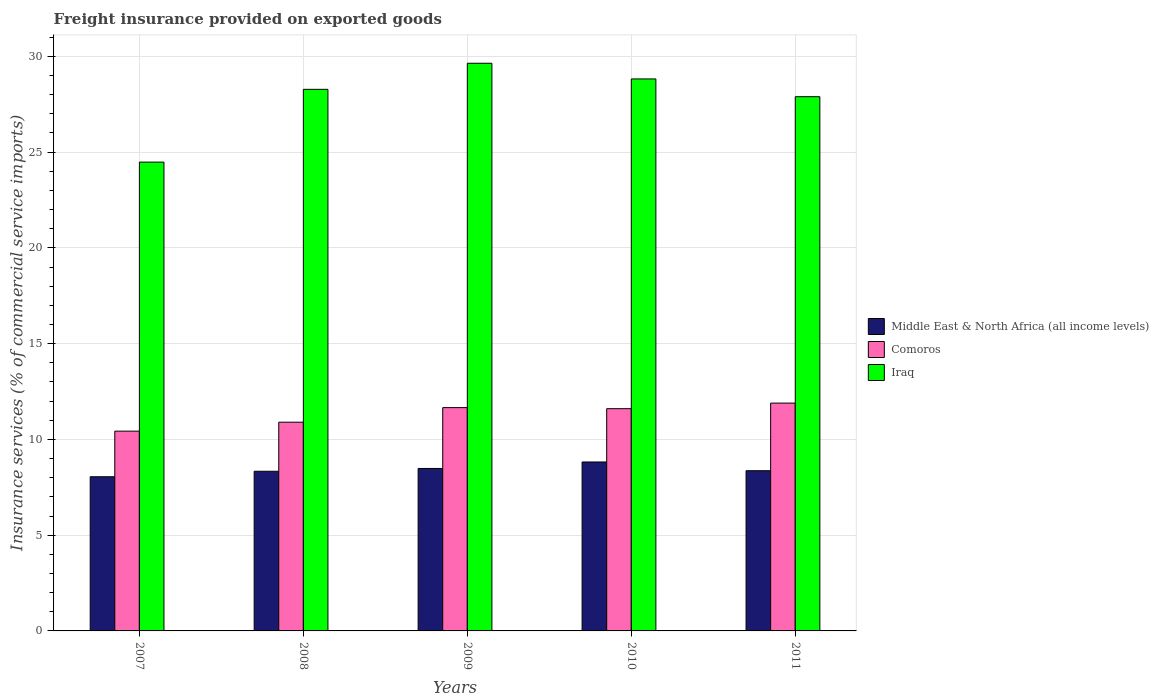How many different coloured bars are there?
Your response must be concise. 3. How many groups of bars are there?
Give a very brief answer. 5. How many bars are there on the 1st tick from the left?
Make the answer very short. 3. How many bars are there on the 4th tick from the right?
Provide a short and direct response. 3. What is the label of the 5th group of bars from the left?
Make the answer very short. 2011. What is the freight insurance provided on exported goods in Comoros in 2008?
Keep it short and to the point. 10.9. Across all years, what is the maximum freight insurance provided on exported goods in Middle East & North Africa (all income levels)?
Keep it short and to the point. 8.82. Across all years, what is the minimum freight insurance provided on exported goods in Comoros?
Ensure brevity in your answer.  10.43. What is the total freight insurance provided on exported goods in Iraq in the graph?
Ensure brevity in your answer.  139.11. What is the difference between the freight insurance provided on exported goods in Iraq in 2007 and that in 2010?
Give a very brief answer. -4.34. What is the difference between the freight insurance provided on exported goods in Middle East & North Africa (all income levels) in 2007 and the freight insurance provided on exported goods in Iraq in 2009?
Make the answer very short. -21.59. What is the average freight insurance provided on exported goods in Iraq per year?
Provide a short and direct response. 27.82. In the year 2009, what is the difference between the freight insurance provided on exported goods in Comoros and freight insurance provided on exported goods in Iraq?
Keep it short and to the point. -17.98. In how many years, is the freight insurance provided on exported goods in Middle East & North Africa (all income levels) greater than 30 %?
Your answer should be compact. 0. What is the ratio of the freight insurance provided on exported goods in Iraq in 2007 to that in 2011?
Ensure brevity in your answer.  0.88. Is the difference between the freight insurance provided on exported goods in Comoros in 2010 and 2011 greater than the difference between the freight insurance provided on exported goods in Iraq in 2010 and 2011?
Your answer should be very brief. No. What is the difference between the highest and the second highest freight insurance provided on exported goods in Iraq?
Make the answer very short. 0.82. What is the difference between the highest and the lowest freight insurance provided on exported goods in Comoros?
Your answer should be compact. 1.46. In how many years, is the freight insurance provided on exported goods in Comoros greater than the average freight insurance provided on exported goods in Comoros taken over all years?
Keep it short and to the point. 3. What does the 1st bar from the left in 2011 represents?
Your answer should be compact. Middle East & North Africa (all income levels). What does the 2nd bar from the right in 2008 represents?
Offer a very short reply. Comoros. Is it the case that in every year, the sum of the freight insurance provided on exported goods in Iraq and freight insurance provided on exported goods in Comoros is greater than the freight insurance provided on exported goods in Middle East & North Africa (all income levels)?
Offer a terse response. Yes. Does the graph contain any zero values?
Make the answer very short. No. Does the graph contain grids?
Provide a short and direct response. Yes. Where does the legend appear in the graph?
Offer a very short reply. Center right. How many legend labels are there?
Provide a short and direct response. 3. How are the legend labels stacked?
Make the answer very short. Vertical. What is the title of the graph?
Offer a very short reply. Freight insurance provided on exported goods. What is the label or title of the Y-axis?
Your answer should be very brief. Insurance services (% of commercial service imports). What is the Insurance services (% of commercial service imports) in Middle East & North Africa (all income levels) in 2007?
Offer a terse response. 8.05. What is the Insurance services (% of commercial service imports) in Comoros in 2007?
Offer a terse response. 10.43. What is the Insurance services (% of commercial service imports) of Iraq in 2007?
Ensure brevity in your answer.  24.48. What is the Insurance services (% of commercial service imports) in Middle East & North Africa (all income levels) in 2008?
Provide a succinct answer. 8.34. What is the Insurance services (% of commercial service imports) of Comoros in 2008?
Your answer should be very brief. 10.9. What is the Insurance services (% of commercial service imports) in Iraq in 2008?
Ensure brevity in your answer.  28.28. What is the Insurance services (% of commercial service imports) of Middle East & North Africa (all income levels) in 2009?
Your response must be concise. 8.48. What is the Insurance services (% of commercial service imports) of Comoros in 2009?
Provide a short and direct response. 11.66. What is the Insurance services (% of commercial service imports) of Iraq in 2009?
Provide a succinct answer. 29.64. What is the Insurance services (% of commercial service imports) of Middle East & North Africa (all income levels) in 2010?
Keep it short and to the point. 8.82. What is the Insurance services (% of commercial service imports) of Comoros in 2010?
Ensure brevity in your answer.  11.6. What is the Insurance services (% of commercial service imports) of Iraq in 2010?
Your response must be concise. 28.82. What is the Insurance services (% of commercial service imports) in Middle East & North Africa (all income levels) in 2011?
Make the answer very short. 8.36. What is the Insurance services (% of commercial service imports) in Comoros in 2011?
Make the answer very short. 11.9. What is the Insurance services (% of commercial service imports) of Iraq in 2011?
Provide a succinct answer. 27.89. Across all years, what is the maximum Insurance services (% of commercial service imports) in Middle East & North Africa (all income levels)?
Make the answer very short. 8.82. Across all years, what is the maximum Insurance services (% of commercial service imports) in Comoros?
Ensure brevity in your answer.  11.9. Across all years, what is the maximum Insurance services (% of commercial service imports) in Iraq?
Give a very brief answer. 29.64. Across all years, what is the minimum Insurance services (% of commercial service imports) in Middle East & North Africa (all income levels)?
Your response must be concise. 8.05. Across all years, what is the minimum Insurance services (% of commercial service imports) in Comoros?
Your answer should be compact. 10.43. Across all years, what is the minimum Insurance services (% of commercial service imports) of Iraq?
Offer a terse response. 24.48. What is the total Insurance services (% of commercial service imports) of Middle East & North Africa (all income levels) in the graph?
Your response must be concise. 42.05. What is the total Insurance services (% of commercial service imports) in Comoros in the graph?
Keep it short and to the point. 56.49. What is the total Insurance services (% of commercial service imports) in Iraq in the graph?
Offer a terse response. 139.11. What is the difference between the Insurance services (% of commercial service imports) of Middle East & North Africa (all income levels) in 2007 and that in 2008?
Your response must be concise. -0.29. What is the difference between the Insurance services (% of commercial service imports) of Comoros in 2007 and that in 2008?
Provide a short and direct response. -0.47. What is the difference between the Insurance services (% of commercial service imports) of Iraq in 2007 and that in 2008?
Your response must be concise. -3.8. What is the difference between the Insurance services (% of commercial service imports) in Middle East & North Africa (all income levels) in 2007 and that in 2009?
Provide a succinct answer. -0.43. What is the difference between the Insurance services (% of commercial service imports) of Comoros in 2007 and that in 2009?
Provide a short and direct response. -1.23. What is the difference between the Insurance services (% of commercial service imports) in Iraq in 2007 and that in 2009?
Provide a succinct answer. -5.16. What is the difference between the Insurance services (% of commercial service imports) of Middle East & North Africa (all income levels) in 2007 and that in 2010?
Your response must be concise. -0.77. What is the difference between the Insurance services (% of commercial service imports) in Comoros in 2007 and that in 2010?
Provide a succinct answer. -1.17. What is the difference between the Insurance services (% of commercial service imports) of Iraq in 2007 and that in 2010?
Your answer should be very brief. -4.34. What is the difference between the Insurance services (% of commercial service imports) of Middle East & North Africa (all income levels) in 2007 and that in 2011?
Ensure brevity in your answer.  -0.31. What is the difference between the Insurance services (% of commercial service imports) in Comoros in 2007 and that in 2011?
Provide a short and direct response. -1.46. What is the difference between the Insurance services (% of commercial service imports) of Iraq in 2007 and that in 2011?
Give a very brief answer. -3.42. What is the difference between the Insurance services (% of commercial service imports) of Middle East & North Africa (all income levels) in 2008 and that in 2009?
Keep it short and to the point. -0.15. What is the difference between the Insurance services (% of commercial service imports) of Comoros in 2008 and that in 2009?
Offer a terse response. -0.76. What is the difference between the Insurance services (% of commercial service imports) of Iraq in 2008 and that in 2009?
Provide a short and direct response. -1.36. What is the difference between the Insurance services (% of commercial service imports) in Middle East & North Africa (all income levels) in 2008 and that in 2010?
Provide a short and direct response. -0.48. What is the difference between the Insurance services (% of commercial service imports) in Comoros in 2008 and that in 2010?
Offer a very short reply. -0.71. What is the difference between the Insurance services (% of commercial service imports) in Iraq in 2008 and that in 2010?
Offer a very short reply. -0.54. What is the difference between the Insurance services (% of commercial service imports) in Middle East & North Africa (all income levels) in 2008 and that in 2011?
Offer a terse response. -0.03. What is the difference between the Insurance services (% of commercial service imports) in Comoros in 2008 and that in 2011?
Offer a very short reply. -1. What is the difference between the Insurance services (% of commercial service imports) of Iraq in 2008 and that in 2011?
Your response must be concise. 0.38. What is the difference between the Insurance services (% of commercial service imports) in Middle East & North Africa (all income levels) in 2009 and that in 2010?
Offer a terse response. -0.34. What is the difference between the Insurance services (% of commercial service imports) of Comoros in 2009 and that in 2010?
Make the answer very short. 0.06. What is the difference between the Insurance services (% of commercial service imports) in Iraq in 2009 and that in 2010?
Keep it short and to the point. 0.82. What is the difference between the Insurance services (% of commercial service imports) in Middle East & North Africa (all income levels) in 2009 and that in 2011?
Your answer should be compact. 0.12. What is the difference between the Insurance services (% of commercial service imports) in Comoros in 2009 and that in 2011?
Keep it short and to the point. -0.24. What is the difference between the Insurance services (% of commercial service imports) of Iraq in 2009 and that in 2011?
Your response must be concise. 1.75. What is the difference between the Insurance services (% of commercial service imports) of Middle East & North Africa (all income levels) in 2010 and that in 2011?
Your answer should be compact. 0.46. What is the difference between the Insurance services (% of commercial service imports) in Comoros in 2010 and that in 2011?
Your answer should be compact. -0.29. What is the difference between the Insurance services (% of commercial service imports) in Iraq in 2010 and that in 2011?
Make the answer very short. 0.93. What is the difference between the Insurance services (% of commercial service imports) of Middle East & North Africa (all income levels) in 2007 and the Insurance services (% of commercial service imports) of Comoros in 2008?
Keep it short and to the point. -2.85. What is the difference between the Insurance services (% of commercial service imports) of Middle East & North Africa (all income levels) in 2007 and the Insurance services (% of commercial service imports) of Iraq in 2008?
Provide a succinct answer. -20.23. What is the difference between the Insurance services (% of commercial service imports) in Comoros in 2007 and the Insurance services (% of commercial service imports) in Iraq in 2008?
Offer a very short reply. -17.85. What is the difference between the Insurance services (% of commercial service imports) in Middle East & North Africa (all income levels) in 2007 and the Insurance services (% of commercial service imports) in Comoros in 2009?
Provide a succinct answer. -3.61. What is the difference between the Insurance services (% of commercial service imports) of Middle East & North Africa (all income levels) in 2007 and the Insurance services (% of commercial service imports) of Iraq in 2009?
Offer a terse response. -21.59. What is the difference between the Insurance services (% of commercial service imports) in Comoros in 2007 and the Insurance services (% of commercial service imports) in Iraq in 2009?
Make the answer very short. -19.21. What is the difference between the Insurance services (% of commercial service imports) in Middle East & North Africa (all income levels) in 2007 and the Insurance services (% of commercial service imports) in Comoros in 2010?
Give a very brief answer. -3.55. What is the difference between the Insurance services (% of commercial service imports) of Middle East & North Africa (all income levels) in 2007 and the Insurance services (% of commercial service imports) of Iraq in 2010?
Your answer should be very brief. -20.77. What is the difference between the Insurance services (% of commercial service imports) of Comoros in 2007 and the Insurance services (% of commercial service imports) of Iraq in 2010?
Ensure brevity in your answer.  -18.39. What is the difference between the Insurance services (% of commercial service imports) in Middle East & North Africa (all income levels) in 2007 and the Insurance services (% of commercial service imports) in Comoros in 2011?
Your response must be concise. -3.85. What is the difference between the Insurance services (% of commercial service imports) of Middle East & North Africa (all income levels) in 2007 and the Insurance services (% of commercial service imports) of Iraq in 2011?
Ensure brevity in your answer.  -19.84. What is the difference between the Insurance services (% of commercial service imports) in Comoros in 2007 and the Insurance services (% of commercial service imports) in Iraq in 2011?
Provide a short and direct response. -17.46. What is the difference between the Insurance services (% of commercial service imports) of Middle East & North Africa (all income levels) in 2008 and the Insurance services (% of commercial service imports) of Comoros in 2009?
Provide a short and direct response. -3.32. What is the difference between the Insurance services (% of commercial service imports) of Middle East & North Africa (all income levels) in 2008 and the Insurance services (% of commercial service imports) of Iraq in 2009?
Give a very brief answer. -21.3. What is the difference between the Insurance services (% of commercial service imports) of Comoros in 2008 and the Insurance services (% of commercial service imports) of Iraq in 2009?
Keep it short and to the point. -18.74. What is the difference between the Insurance services (% of commercial service imports) in Middle East & North Africa (all income levels) in 2008 and the Insurance services (% of commercial service imports) in Comoros in 2010?
Provide a succinct answer. -3.27. What is the difference between the Insurance services (% of commercial service imports) in Middle East & North Africa (all income levels) in 2008 and the Insurance services (% of commercial service imports) in Iraq in 2010?
Your response must be concise. -20.48. What is the difference between the Insurance services (% of commercial service imports) in Comoros in 2008 and the Insurance services (% of commercial service imports) in Iraq in 2010?
Provide a short and direct response. -17.92. What is the difference between the Insurance services (% of commercial service imports) in Middle East & North Africa (all income levels) in 2008 and the Insurance services (% of commercial service imports) in Comoros in 2011?
Make the answer very short. -3.56. What is the difference between the Insurance services (% of commercial service imports) of Middle East & North Africa (all income levels) in 2008 and the Insurance services (% of commercial service imports) of Iraq in 2011?
Provide a short and direct response. -19.56. What is the difference between the Insurance services (% of commercial service imports) in Comoros in 2008 and the Insurance services (% of commercial service imports) in Iraq in 2011?
Your response must be concise. -17. What is the difference between the Insurance services (% of commercial service imports) in Middle East & North Africa (all income levels) in 2009 and the Insurance services (% of commercial service imports) in Comoros in 2010?
Offer a terse response. -3.12. What is the difference between the Insurance services (% of commercial service imports) of Middle East & North Africa (all income levels) in 2009 and the Insurance services (% of commercial service imports) of Iraq in 2010?
Your response must be concise. -20.34. What is the difference between the Insurance services (% of commercial service imports) in Comoros in 2009 and the Insurance services (% of commercial service imports) in Iraq in 2010?
Offer a terse response. -17.16. What is the difference between the Insurance services (% of commercial service imports) in Middle East & North Africa (all income levels) in 2009 and the Insurance services (% of commercial service imports) in Comoros in 2011?
Your response must be concise. -3.41. What is the difference between the Insurance services (% of commercial service imports) of Middle East & North Africa (all income levels) in 2009 and the Insurance services (% of commercial service imports) of Iraq in 2011?
Your answer should be compact. -19.41. What is the difference between the Insurance services (% of commercial service imports) of Comoros in 2009 and the Insurance services (% of commercial service imports) of Iraq in 2011?
Make the answer very short. -16.23. What is the difference between the Insurance services (% of commercial service imports) of Middle East & North Africa (all income levels) in 2010 and the Insurance services (% of commercial service imports) of Comoros in 2011?
Make the answer very short. -3.07. What is the difference between the Insurance services (% of commercial service imports) of Middle East & North Africa (all income levels) in 2010 and the Insurance services (% of commercial service imports) of Iraq in 2011?
Your answer should be very brief. -19.07. What is the difference between the Insurance services (% of commercial service imports) of Comoros in 2010 and the Insurance services (% of commercial service imports) of Iraq in 2011?
Your answer should be compact. -16.29. What is the average Insurance services (% of commercial service imports) of Middle East & North Africa (all income levels) per year?
Keep it short and to the point. 8.41. What is the average Insurance services (% of commercial service imports) in Comoros per year?
Provide a short and direct response. 11.3. What is the average Insurance services (% of commercial service imports) of Iraq per year?
Your response must be concise. 27.82. In the year 2007, what is the difference between the Insurance services (% of commercial service imports) of Middle East & North Africa (all income levels) and Insurance services (% of commercial service imports) of Comoros?
Make the answer very short. -2.38. In the year 2007, what is the difference between the Insurance services (% of commercial service imports) of Middle East & North Africa (all income levels) and Insurance services (% of commercial service imports) of Iraq?
Make the answer very short. -16.43. In the year 2007, what is the difference between the Insurance services (% of commercial service imports) of Comoros and Insurance services (% of commercial service imports) of Iraq?
Give a very brief answer. -14.05. In the year 2008, what is the difference between the Insurance services (% of commercial service imports) of Middle East & North Africa (all income levels) and Insurance services (% of commercial service imports) of Comoros?
Keep it short and to the point. -2.56. In the year 2008, what is the difference between the Insurance services (% of commercial service imports) in Middle East & North Africa (all income levels) and Insurance services (% of commercial service imports) in Iraq?
Provide a succinct answer. -19.94. In the year 2008, what is the difference between the Insurance services (% of commercial service imports) in Comoros and Insurance services (% of commercial service imports) in Iraq?
Offer a very short reply. -17.38. In the year 2009, what is the difference between the Insurance services (% of commercial service imports) of Middle East & North Africa (all income levels) and Insurance services (% of commercial service imports) of Comoros?
Give a very brief answer. -3.18. In the year 2009, what is the difference between the Insurance services (% of commercial service imports) in Middle East & North Africa (all income levels) and Insurance services (% of commercial service imports) in Iraq?
Give a very brief answer. -21.16. In the year 2009, what is the difference between the Insurance services (% of commercial service imports) of Comoros and Insurance services (% of commercial service imports) of Iraq?
Offer a terse response. -17.98. In the year 2010, what is the difference between the Insurance services (% of commercial service imports) of Middle East & North Africa (all income levels) and Insurance services (% of commercial service imports) of Comoros?
Your answer should be compact. -2.78. In the year 2010, what is the difference between the Insurance services (% of commercial service imports) of Middle East & North Africa (all income levels) and Insurance services (% of commercial service imports) of Iraq?
Keep it short and to the point. -20. In the year 2010, what is the difference between the Insurance services (% of commercial service imports) of Comoros and Insurance services (% of commercial service imports) of Iraq?
Offer a terse response. -17.22. In the year 2011, what is the difference between the Insurance services (% of commercial service imports) of Middle East & North Africa (all income levels) and Insurance services (% of commercial service imports) of Comoros?
Your response must be concise. -3.53. In the year 2011, what is the difference between the Insurance services (% of commercial service imports) of Middle East & North Africa (all income levels) and Insurance services (% of commercial service imports) of Iraq?
Your answer should be compact. -19.53. In the year 2011, what is the difference between the Insurance services (% of commercial service imports) of Comoros and Insurance services (% of commercial service imports) of Iraq?
Give a very brief answer. -16. What is the ratio of the Insurance services (% of commercial service imports) in Middle East & North Africa (all income levels) in 2007 to that in 2008?
Give a very brief answer. 0.97. What is the ratio of the Insurance services (% of commercial service imports) in Comoros in 2007 to that in 2008?
Ensure brevity in your answer.  0.96. What is the ratio of the Insurance services (% of commercial service imports) in Iraq in 2007 to that in 2008?
Your answer should be compact. 0.87. What is the ratio of the Insurance services (% of commercial service imports) of Middle East & North Africa (all income levels) in 2007 to that in 2009?
Provide a succinct answer. 0.95. What is the ratio of the Insurance services (% of commercial service imports) in Comoros in 2007 to that in 2009?
Ensure brevity in your answer.  0.89. What is the ratio of the Insurance services (% of commercial service imports) of Iraq in 2007 to that in 2009?
Offer a terse response. 0.83. What is the ratio of the Insurance services (% of commercial service imports) in Middle East & North Africa (all income levels) in 2007 to that in 2010?
Your response must be concise. 0.91. What is the ratio of the Insurance services (% of commercial service imports) of Comoros in 2007 to that in 2010?
Offer a terse response. 0.9. What is the ratio of the Insurance services (% of commercial service imports) in Iraq in 2007 to that in 2010?
Your answer should be very brief. 0.85. What is the ratio of the Insurance services (% of commercial service imports) in Middle East & North Africa (all income levels) in 2007 to that in 2011?
Provide a short and direct response. 0.96. What is the ratio of the Insurance services (% of commercial service imports) in Comoros in 2007 to that in 2011?
Keep it short and to the point. 0.88. What is the ratio of the Insurance services (% of commercial service imports) in Iraq in 2007 to that in 2011?
Ensure brevity in your answer.  0.88. What is the ratio of the Insurance services (% of commercial service imports) of Middle East & North Africa (all income levels) in 2008 to that in 2009?
Give a very brief answer. 0.98. What is the ratio of the Insurance services (% of commercial service imports) of Comoros in 2008 to that in 2009?
Offer a terse response. 0.93. What is the ratio of the Insurance services (% of commercial service imports) in Iraq in 2008 to that in 2009?
Keep it short and to the point. 0.95. What is the ratio of the Insurance services (% of commercial service imports) of Middle East & North Africa (all income levels) in 2008 to that in 2010?
Make the answer very short. 0.95. What is the ratio of the Insurance services (% of commercial service imports) of Comoros in 2008 to that in 2010?
Ensure brevity in your answer.  0.94. What is the ratio of the Insurance services (% of commercial service imports) in Iraq in 2008 to that in 2010?
Provide a short and direct response. 0.98. What is the ratio of the Insurance services (% of commercial service imports) of Middle East & North Africa (all income levels) in 2008 to that in 2011?
Provide a succinct answer. 1. What is the ratio of the Insurance services (% of commercial service imports) in Comoros in 2008 to that in 2011?
Your answer should be very brief. 0.92. What is the ratio of the Insurance services (% of commercial service imports) in Iraq in 2008 to that in 2011?
Offer a terse response. 1.01. What is the ratio of the Insurance services (% of commercial service imports) of Middle East & North Africa (all income levels) in 2009 to that in 2010?
Keep it short and to the point. 0.96. What is the ratio of the Insurance services (% of commercial service imports) in Comoros in 2009 to that in 2010?
Keep it short and to the point. 1. What is the ratio of the Insurance services (% of commercial service imports) in Iraq in 2009 to that in 2010?
Offer a very short reply. 1.03. What is the ratio of the Insurance services (% of commercial service imports) in Middle East & North Africa (all income levels) in 2009 to that in 2011?
Your answer should be very brief. 1.01. What is the ratio of the Insurance services (% of commercial service imports) of Comoros in 2009 to that in 2011?
Keep it short and to the point. 0.98. What is the ratio of the Insurance services (% of commercial service imports) of Iraq in 2009 to that in 2011?
Ensure brevity in your answer.  1.06. What is the ratio of the Insurance services (% of commercial service imports) of Middle East & North Africa (all income levels) in 2010 to that in 2011?
Offer a very short reply. 1.05. What is the ratio of the Insurance services (% of commercial service imports) in Comoros in 2010 to that in 2011?
Your answer should be compact. 0.98. What is the ratio of the Insurance services (% of commercial service imports) of Iraq in 2010 to that in 2011?
Provide a short and direct response. 1.03. What is the difference between the highest and the second highest Insurance services (% of commercial service imports) in Middle East & North Africa (all income levels)?
Keep it short and to the point. 0.34. What is the difference between the highest and the second highest Insurance services (% of commercial service imports) in Comoros?
Provide a succinct answer. 0.24. What is the difference between the highest and the second highest Insurance services (% of commercial service imports) of Iraq?
Ensure brevity in your answer.  0.82. What is the difference between the highest and the lowest Insurance services (% of commercial service imports) of Middle East & North Africa (all income levels)?
Offer a very short reply. 0.77. What is the difference between the highest and the lowest Insurance services (% of commercial service imports) of Comoros?
Your response must be concise. 1.46. What is the difference between the highest and the lowest Insurance services (% of commercial service imports) in Iraq?
Offer a very short reply. 5.16. 